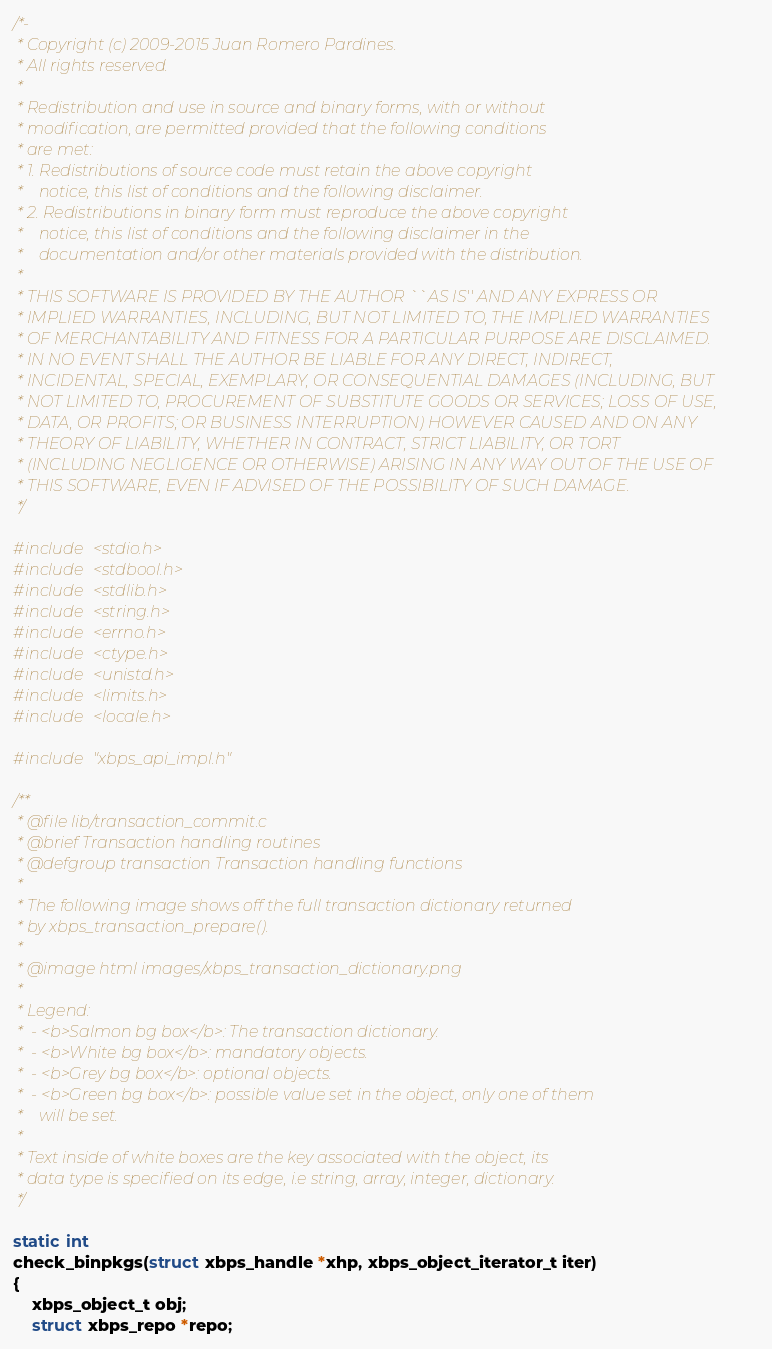Convert code to text. <code><loc_0><loc_0><loc_500><loc_500><_C_>/*-
 * Copyright (c) 2009-2015 Juan Romero Pardines.
 * All rights reserved.
 *
 * Redistribution and use in source and binary forms, with or without
 * modification, are permitted provided that the following conditions
 * are met:
 * 1. Redistributions of source code must retain the above copyright
 *    notice, this list of conditions and the following disclaimer.
 * 2. Redistributions in binary form must reproduce the above copyright
 *    notice, this list of conditions and the following disclaimer in the
 *    documentation and/or other materials provided with the distribution.
 *
 * THIS SOFTWARE IS PROVIDED BY THE AUTHOR ``AS IS'' AND ANY EXPRESS OR
 * IMPLIED WARRANTIES, INCLUDING, BUT NOT LIMITED TO, THE IMPLIED WARRANTIES
 * OF MERCHANTABILITY AND FITNESS FOR A PARTICULAR PURPOSE ARE DISCLAIMED.
 * IN NO EVENT SHALL THE AUTHOR BE LIABLE FOR ANY DIRECT, INDIRECT,
 * INCIDENTAL, SPECIAL, EXEMPLARY, OR CONSEQUENTIAL DAMAGES (INCLUDING, BUT
 * NOT LIMITED TO, PROCUREMENT OF SUBSTITUTE GOODS OR SERVICES; LOSS OF USE,
 * DATA, OR PROFITS; OR BUSINESS INTERRUPTION) HOWEVER CAUSED AND ON ANY
 * THEORY OF LIABILITY, WHETHER IN CONTRACT, STRICT LIABILITY, OR TORT
 * (INCLUDING NEGLIGENCE OR OTHERWISE) ARISING IN ANY WAY OUT OF THE USE OF
 * THIS SOFTWARE, EVEN IF ADVISED OF THE POSSIBILITY OF SUCH DAMAGE.
 */

#include <stdio.h>
#include <stdbool.h>
#include <stdlib.h>
#include <string.h>
#include <errno.h>
#include <ctype.h>
#include <unistd.h>
#include <limits.h>
#include <locale.h>

#include "xbps_api_impl.h"

/**
 * @file lib/transaction_commit.c
 * @brief Transaction handling routines
 * @defgroup transaction Transaction handling functions
 *
 * The following image shows off the full transaction dictionary returned
 * by xbps_transaction_prepare().
 *
 * @image html images/xbps_transaction_dictionary.png
 *
 * Legend:
 *  - <b>Salmon bg box</b>: The transaction dictionary.
 *  - <b>White bg box</b>: mandatory objects.
 *  - <b>Grey bg box</b>: optional objects.
 *  - <b>Green bg box</b>: possible value set in the object, only one of them
 *    will be set.
 *
 * Text inside of white boxes are the key associated with the object, its
 * data type is specified on its edge, i.e string, array, integer, dictionary.
 */

static int
check_binpkgs(struct xbps_handle *xhp, xbps_object_iterator_t iter)
{
	xbps_object_t obj;
	struct xbps_repo *repo;</code> 